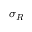<formula> <loc_0><loc_0><loc_500><loc_500>\sigma _ { R }</formula> 